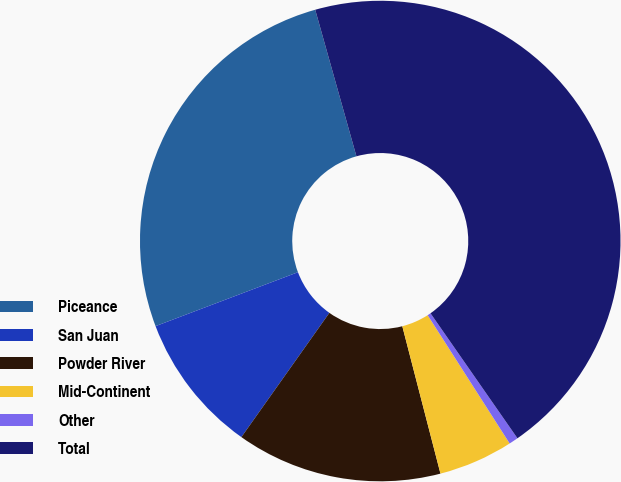Convert chart to OTSL. <chart><loc_0><loc_0><loc_500><loc_500><pie_chart><fcel>Piceance<fcel>San Juan<fcel>Powder River<fcel>Mid-Continent<fcel>Other<fcel>Total<nl><fcel>26.4%<fcel>9.43%<fcel>13.84%<fcel>5.02%<fcel>0.62%<fcel>44.69%<nl></chart> 